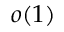<formula> <loc_0><loc_0><loc_500><loc_500>o ( 1 )</formula> 